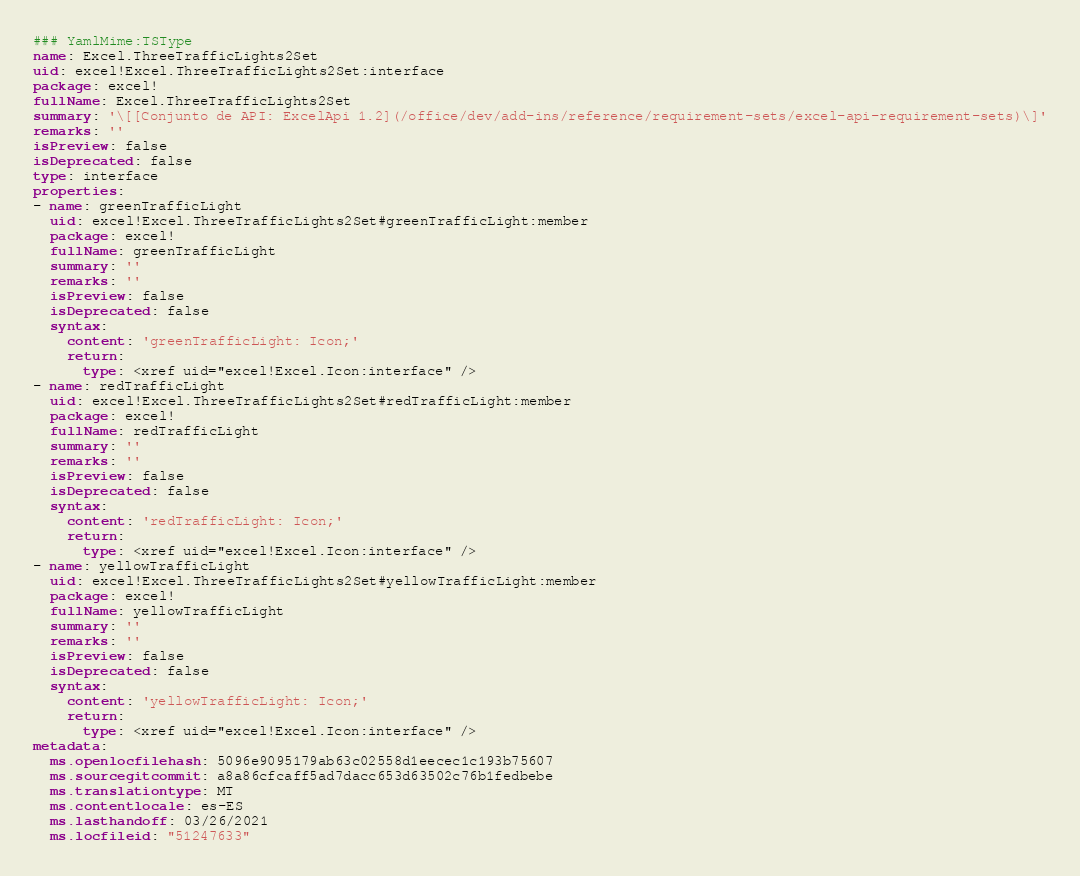Convert code to text. <code><loc_0><loc_0><loc_500><loc_500><_YAML_>### YamlMime:TSType
name: Excel.ThreeTrafficLights2Set
uid: excel!Excel.ThreeTrafficLights2Set:interface
package: excel!
fullName: Excel.ThreeTrafficLights2Set
summary: '\[[Conjunto de API: ExcelApi 1.2](/office/dev/add-ins/reference/requirement-sets/excel-api-requirement-sets)\]'
remarks: ''
isPreview: false
isDeprecated: false
type: interface
properties:
- name: greenTrafficLight
  uid: excel!Excel.ThreeTrafficLights2Set#greenTrafficLight:member
  package: excel!
  fullName: greenTrafficLight
  summary: ''
  remarks: ''
  isPreview: false
  isDeprecated: false
  syntax:
    content: 'greenTrafficLight: Icon;'
    return:
      type: <xref uid="excel!Excel.Icon:interface" />
- name: redTrafficLight
  uid: excel!Excel.ThreeTrafficLights2Set#redTrafficLight:member
  package: excel!
  fullName: redTrafficLight
  summary: ''
  remarks: ''
  isPreview: false
  isDeprecated: false
  syntax:
    content: 'redTrafficLight: Icon;'
    return:
      type: <xref uid="excel!Excel.Icon:interface" />
- name: yellowTrafficLight
  uid: excel!Excel.ThreeTrafficLights2Set#yellowTrafficLight:member
  package: excel!
  fullName: yellowTrafficLight
  summary: ''
  remarks: ''
  isPreview: false
  isDeprecated: false
  syntax:
    content: 'yellowTrafficLight: Icon;'
    return:
      type: <xref uid="excel!Excel.Icon:interface" />
metadata:
  ms.openlocfilehash: 5096e9095179ab63c02558d1eecec1c193b75607
  ms.sourcegitcommit: a8a86cfcaff5ad7dacc653d63502c76b1fedbebe
  ms.translationtype: MT
  ms.contentlocale: es-ES
  ms.lasthandoff: 03/26/2021
  ms.locfileid: "51247633"
</code> 